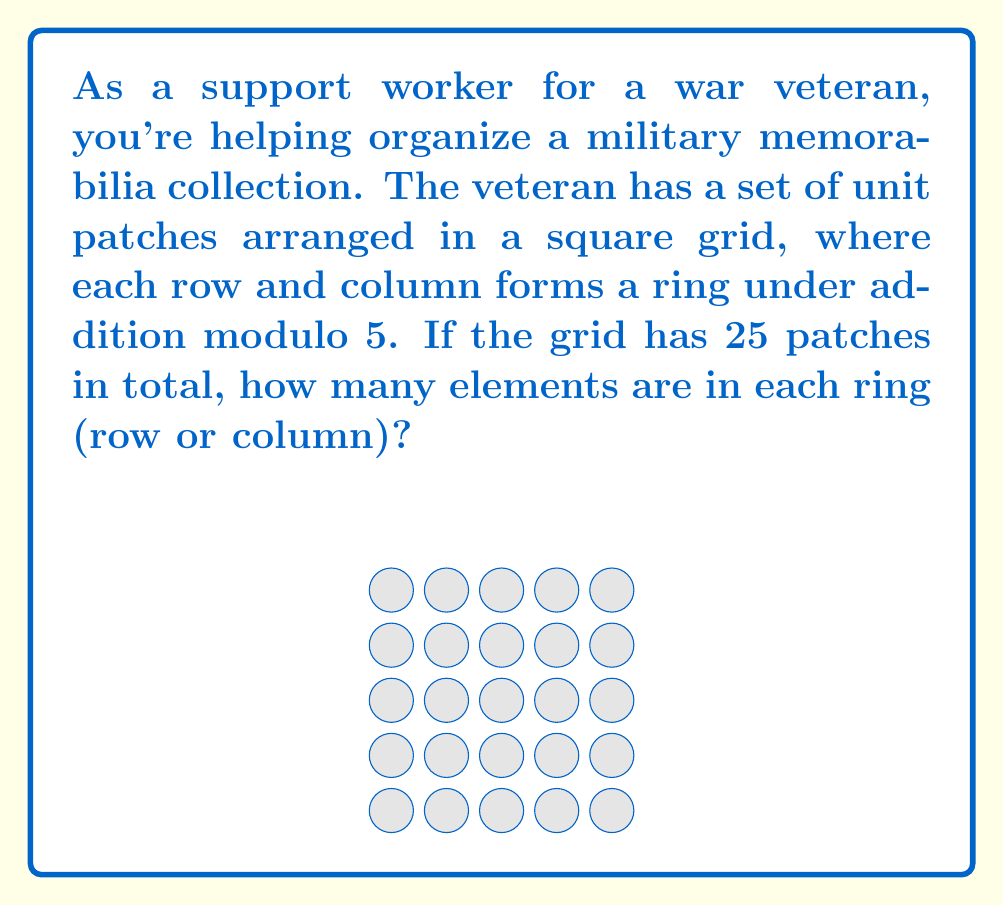Solve this math problem. Let's approach this step-by-step:

1) We're told that the patches are arranged in a square grid with 25 patches in total.

2) The number of patches in each row (or column) can be found by taking the square root of the total number of patches:

   $$\sqrt{25} = 5$$

3) So, each row and each column contains 5 patches.

4) We're also told that each row and column forms a ring under addition modulo 5.

5) In a finite ring, the number of elements is equal to the number of distinct elements in the set.

6) For addition modulo 5, the possible elements are:
   $$\{0, 1, 2, 3, 4\}$$

7) These 5 elements correspond to the 5 patches in each row or column.

Therefore, each ring (row or column) contains 5 elements.
Answer: 5 